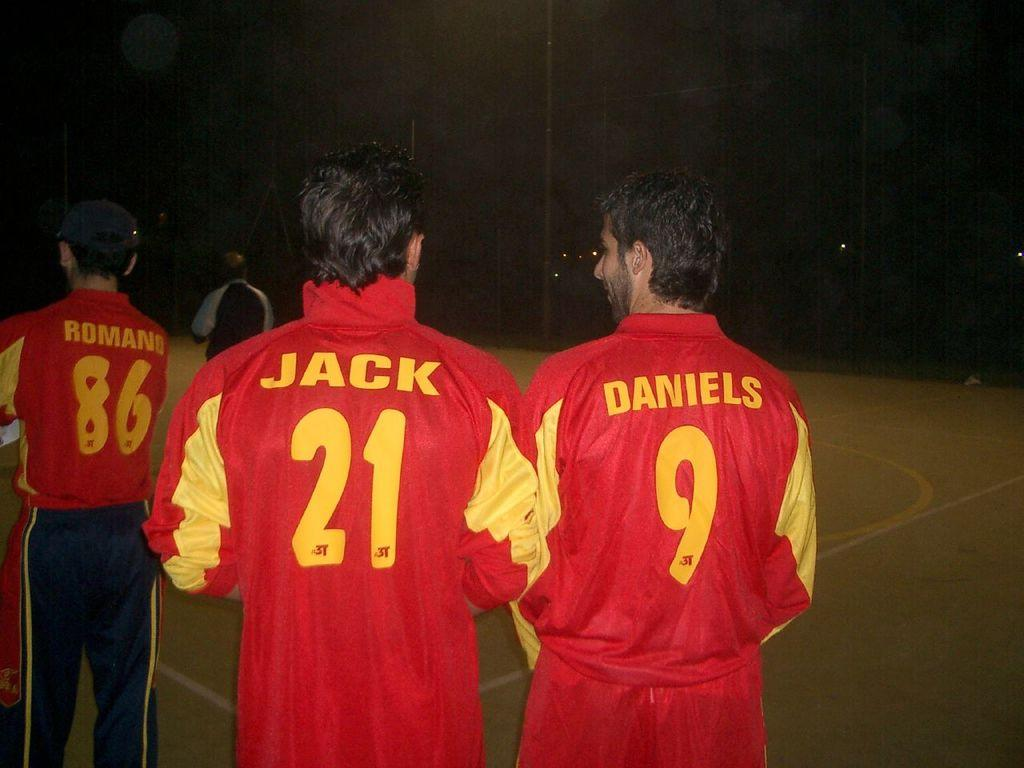<image>
Render a clear and concise summary of the photo. Man wearing a sweater which says number 21 on it. 